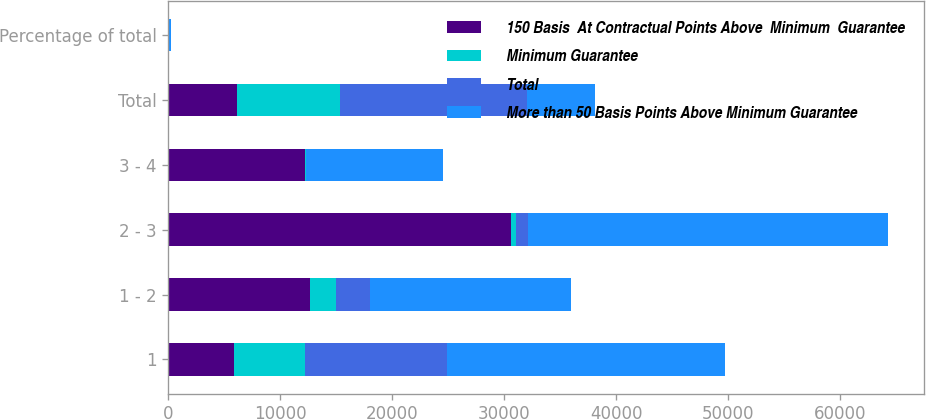<chart> <loc_0><loc_0><loc_500><loc_500><stacked_bar_chart><ecel><fcel>1<fcel>1 - 2<fcel>2 - 3<fcel>3 - 4<fcel>Total<fcel>Percentage of total<nl><fcel>150 Basis  At Contractual Points Above  Minimum  Guarantee<fcel>5896<fcel>12659<fcel>30611<fcel>12231<fcel>6118<fcel>73<nl><fcel>Minimum Guarantee<fcel>6340<fcel>2341<fcel>473<fcel>50<fcel>9204<fcel>10<nl><fcel>Total<fcel>12635<fcel>2974<fcel>1067<fcel>10<fcel>16695<fcel>17<nl><fcel>More than 50 Basis Points Above Minimum Guarantee<fcel>24871<fcel>17974<fcel>32151<fcel>12291<fcel>6118<fcel>100<nl></chart> 